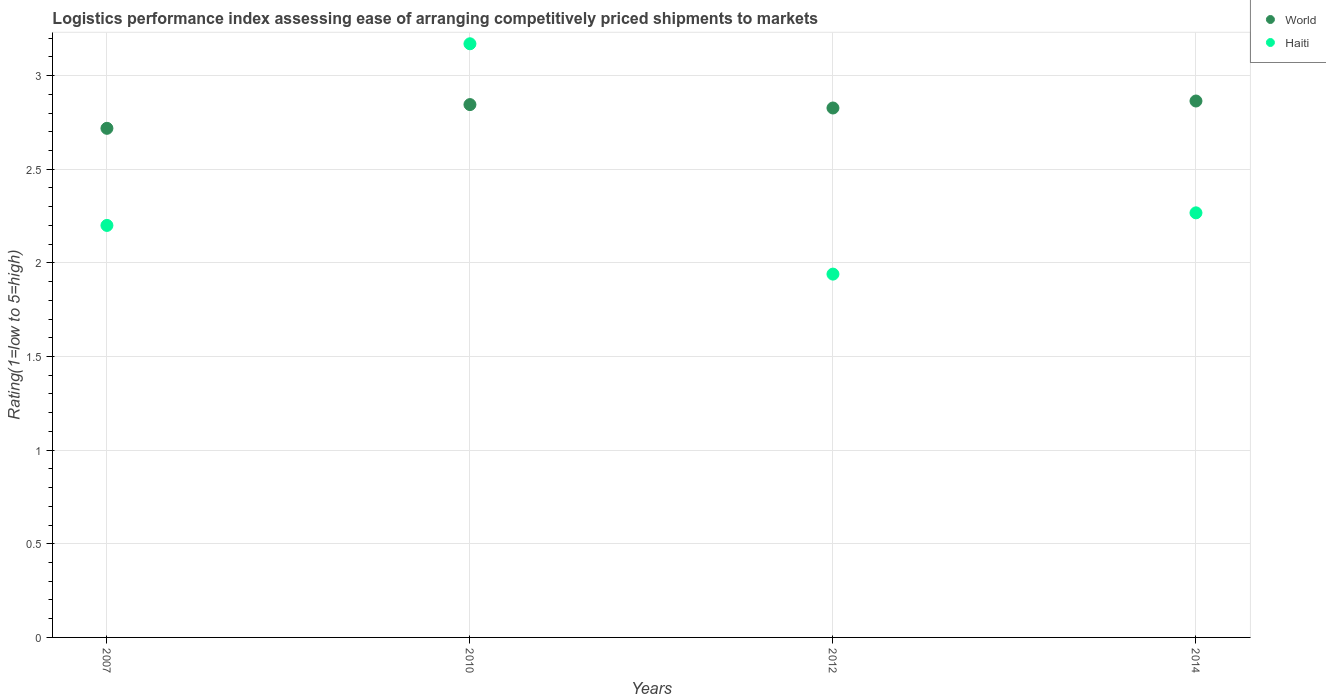Is the number of dotlines equal to the number of legend labels?
Keep it short and to the point. Yes. What is the Logistic performance index in World in 2007?
Ensure brevity in your answer.  2.72. Across all years, what is the maximum Logistic performance index in World?
Your answer should be compact. 2.86. Across all years, what is the minimum Logistic performance index in World?
Keep it short and to the point. 2.72. What is the total Logistic performance index in Haiti in the graph?
Ensure brevity in your answer.  9.58. What is the difference between the Logistic performance index in World in 2010 and that in 2012?
Give a very brief answer. 0.02. What is the difference between the Logistic performance index in World in 2010 and the Logistic performance index in Haiti in 2007?
Give a very brief answer. 0.65. What is the average Logistic performance index in Haiti per year?
Your answer should be compact. 2.39. In the year 2012, what is the difference between the Logistic performance index in World and Logistic performance index in Haiti?
Make the answer very short. 0.89. What is the ratio of the Logistic performance index in Haiti in 2010 to that in 2014?
Offer a very short reply. 1.4. What is the difference between the highest and the second highest Logistic performance index in Haiti?
Offer a terse response. 0.9. What is the difference between the highest and the lowest Logistic performance index in World?
Your response must be concise. 0.15. In how many years, is the Logistic performance index in World greater than the average Logistic performance index in World taken over all years?
Give a very brief answer. 3. Does the Logistic performance index in World monotonically increase over the years?
Your answer should be compact. No. Is the Logistic performance index in World strictly greater than the Logistic performance index in Haiti over the years?
Your response must be concise. No. Is the Logistic performance index in World strictly less than the Logistic performance index in Haiti over the years?
Give a very brief answer. No. How many years are there in the graph?
Provide a short and direct response. 4. What is the difference between two consecutive major ticks on the Y-axis?
Your answer should be very brief. 0.5. Where does the legend appear in the graph?
Offer a very short reply. Top right. What is the title of the graph?
Your response must be concise. Logistics performance index assessing ease of arranging competitively priced shipments to markets. What is the label or title of the Y-axis?
Provide a short and direct response. Rating(1=low to 5=high). What is the Rating(1=low to 5=high) of World in 2007?
Make the answer very short. 2.72. What is the Rating(1=low to 5=high) in World in 2010?
Keep it short and to the point. 2.85. What is the Rating(1=low to 5=high) in Haiti in 2010?
Give a very brief answer. 3.17. What is the Rating(1=low to 5=high) of World in 2012?
Make the answer very short. 2.83. What is the Rating(1=low to 5=high) in Haiti in 2012?
Make the answer very short. 1.94. What is the Rating(1=low to 5=high) in World in 2014?
Your answer should be compact. 2.86. What is the Rating(1=low to 5=high) in Haiti in 2014?
Offer a terse response. 2.27. Across all years, what is the maximum Rating(1=low to 5=high) in World?
Give a very brief answer. 2.86. Across all years, what is the maximum Rating(1=low to 5=high) in Haiti?
Your answer should be compact. 3.17. Across all years, what is the minimum Rating(1=low to 5=high) of World?
Ensure brevity in your answer.  2.72. Across all years, what is the minimum Rating(1=low to 5=high) in Haiti?
Provide a short and direct response. 1.94. What is the total Rating(1=low to 5=high) of World in the graph?
Provide a short and direct response. 11.26. What is the total Rating(1=low to 5=high) of Haiti in the graph?
Your answer should be very brief. 9.58. What is the difference between the Rating(1=low to 5=high) in World in 2007 and that in 2010?
Ensure brevity in your answer.  -0.13. What is the difference between the Rating(1=low to 5=high) of Haiti in 2007 and that in 2010?
Provide a succinct answer. -0.97. What is the difference between the Rating(1=low to 5=high) in World in 2007 and that in 2012?
Offer a terse response. -0.11. What is the difference between the Rating(1=low to 5=high) in Haiti in 2007 and that in 2012?
Make the answer very short. 0.26. What is the difference between the Rating(1=low to 5=high) of World in 2007 and that in 2014?
Your response must be concise. -0.15. What is the difference between the Rating(1=low to 5=high) in Haiti in 2007 and that in 2014?
Your answer should be compact. -0.07. What is the difference between the Rating(1=low to 5=high) in World in 2010 and that in 2012?
Offer a terse response. 0.02. What is the difference between the Rating(1=low to 5=high) of Haiti in 2010 and that in 2012?
Ensure brevity in your answer.  1.23. What is the difference between the Rating(1=low to 5=high) in World in 2010 and that in 2014?
Provide a succinct answer. -0.02. What is the difference between the Rating(1=low to 5=high) of Haiti in 2010 and that in 2014?
Your answer should be compact. 0.9. What is the difference between the Rating(1=low to 5=high) in World in 2012 and that in 2014?
Make the answer very short. -0.04. What is the difference between the Rating(1=low to 5=high) in Haiti in 2012 and that in 2014?
Your answer should be very brief. -0.33. What is the difference between the Rating(1=low to 5=high) in World in 2007 and the Rating(1=low to 5=high) in Haiti in 2010?
Provide a short and direct response. -0.45. What is the difference between the Rating(1=low to 5=high) of World in 2007 and the Rating(1=low to 5=high) of Haiti in 2012?
Your answer should be very brief. 0.78. What is the difference between the Rating(1=low to 5=high) of World in 2007 and the Rating(1=low to 5=high) of Haiti in 2014?
Make the answer very short. 0.45. What is the difference between the Rating(1=low to 5=high) of World in 2010 and the Rating(1=low to 5=high) of Haiti in 2012?
Your answer should be very brief. 0.91. What is the difference between the Rating(1=low to 5=high) in World in 2010 and the Rating(1=low to 5=high) in Haiti in 2014?
Ensure brevity in your answer.  0.58. What is the difference between the Rating(1=low to 5=high) in World in 2012 and the Rating(1=low to 5=high) in Haiti in 2014?
Offer a terse response. 0.56. What is the average Rating(1=low to 5=high) of World per year?
Make the answer very short. 2.81. What is the average Rating(1=low to 5=high) in Haiti per year?
Offer a very short reply. 2.39. In the year 2007, what is the difference between the Rating(1=low to 5=high) in World and Rating(1=low to 5=high) in Haiti?
Offer a very short reply. 0.52. In the year 2010, what is the difference between the Rating(1=low to 5=high) of World and Rating(1=low to 5=high) of Haiti?
Keep it short and to the point. -0.32. In the year 2012, what is the difference between the Rating(1=low to 5=high) in World and Rating(1=low to 5=high) in Haiti?
Give a very brief answer. 0.89. In the year 2014, what is the difference between the Rating(1=low to 5=high) in World and Rating(1=low to 5=high) in Haiti?
Provide a short and direct response. 0.6. What is the ratio of the Rating(1=low to 5=high) of World in 2007 to that in 2010?
Keep it short and to the point. 0.96. What is the ratio of the Rating(1=low to 5=high) in Haiti in 2007 to that in 2010?
Your answer should be compact. 0.69. What is the ratio of the Rating(1=low to 5=high) in World in 2007 to that in 2012?
Make the answer very short. 0.96. What is the ratio of the Rating(1=low to 5=high) in Haiti in 2007 to that in 2012?
Ensure brevity in your answer.  1.13. What is the ratio of the Rating(1=low to 5=high) in World in 2007 to that in 2014?
Provide a succinct answer. 0.95. What is the ratio of the Rating(1=low to 5=high) in Haiti in 2007 to that in 2014?
Give a very brief answer. 0.97. What is the ratio of the Rating(1=low to 5=high) in World in 2010 to that in 2012?
Your answer should be very brief. 1.01. What is the ratio of the Rating(1=low to 5=high) in Haiti in 2010 to that in 2012?
Provide a short and direct response. 1.63. What is the ratio of the Rating(1=low to 5=high) in World in 2010 to that in 2014?
Ensure brevity in your answer.  0.99. What is the ratio of the Rating(1=low to 5=high) of Haiti in 2010 to that in 2014?
Offer a very short reply. 1.4. What is the ratio of the Rating(1=low to 5=high) in World in 2012 to that in 2014?
Make the answer very short. 0.99. What is the ratio of the Rating(1=low to 5=high) in Haiti in 2012 to that in 2014?
Offer a terse response. 0.86. What is the difference between the highest and the second highest Rating(1=low to 5=high) of World?
Provide a succinct answer. 0.02. What is the difference between the highest and the second highest Rating(1=low to 5=high) of Haiti?
Keep it short and to the point. 0.9. What is the difference between the highest and the lowest Rating(1=low to 5=high) in World?
Your answer should be very brief. 0.15. What is the difference between the highest and the lowest Rating(1=low to 5=high) of Haiti?
Provide a succinct answer. 1.23. 